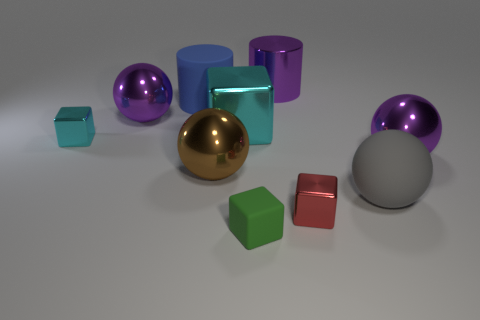Do the blue rubber thing and the block right of the tiny green rubber cube have the same size?
Make the answer very short. No. What number of matte things are either blue cubes or large purple cylinders?
Your response must be concise. 0. What number of red metal objects have the same shape as the small green rubber thing?
Your answer should be compact. 1. There is a tiny block that is the same color as the big shiny block; what is it made of?
Keep it short and to the point. Metal. Is the size of the cyan block to the right of the small cyan object the same as the sphere that is behind the small cyan metallic block?
Your response must be concise. Yes. There is a purple shiny object behind the blue cylinder; what is its shape?
Ensure brevity in your answer.  Cylinder. There is a red thing that is the same shape as the green rubber thing; what material is it?
Your answer should be very brief. Metal. There is a brown sphere that is on the left side of the purple cylinder; does it have the same size as the large rubber cylinder?
Your answer should be very brief. Yes. There is a big blue rubber object; what number of large shiny cubes are behind it?
Provide a short and direct response. 0. Are there fewer big cyan metallic objects in front of the matte block than big blue things that are left of the red shiny block?
Offer a very short reply. Yes. 